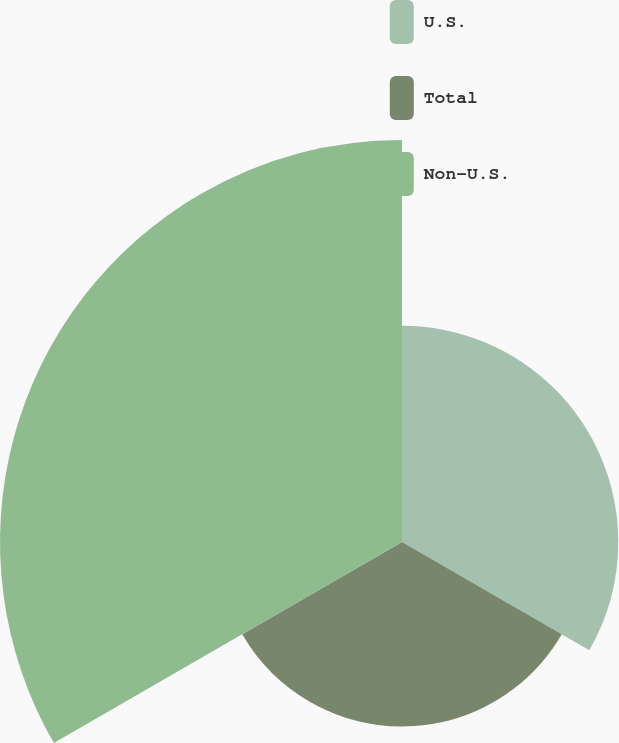Convert chart. <chart><loc_0><loc_0><loc_500><loc_500><pie_chart><fcel>U.S.<fcel>Total<fcel>Non-U.S.<nl><fcel>26.94%<fcel>22.98%<fcel>50.08%<nl></chart> 